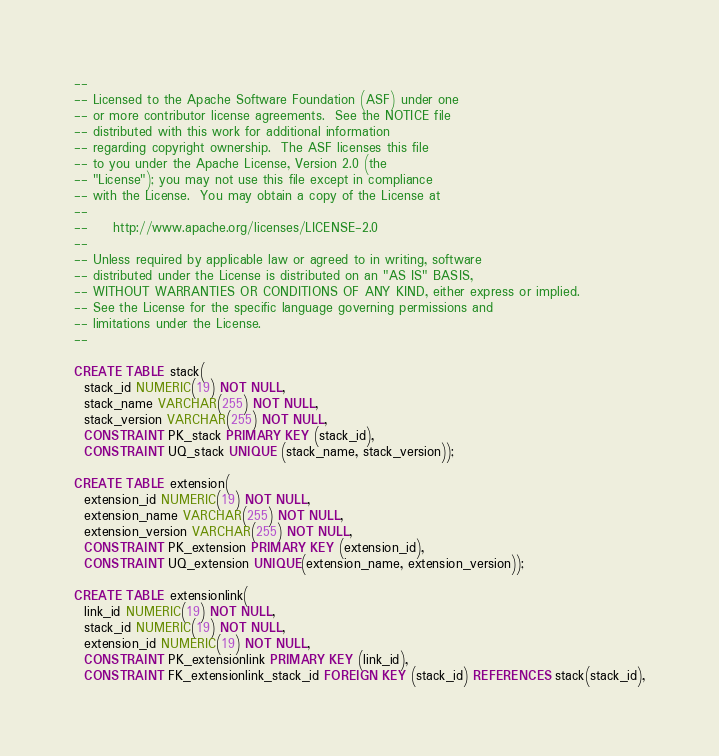<code> <loc_0><loc_0><loc_500><loc_500><_SQL_>--
-- Licensed to the Apache Software Foundation (ASF) under one
-- or more contributor license agreements.  See the NOTICE file
-- distributed with this work for additional information
-- regarding copyright ownership.  The ASF licenses this file
-- to you under the Apache License, Version 2.0 (the
-- "License"); you may not use this file except in compliance
-- with the License.  You may obtain a copy of the License at
--
--     http://www.apache.org/licenses/LICENSE-2.0
--
-- Unless required by applicable law or agreed to in writing, software
-- distributed under the License is distributed on an "AS IS" BASIS,
-- WITHOUT WARRANTIES OR CONDITIONS OF ANY KIND, either express or implied.
-- See the License for the specific language governing permissions and
-- limitations under the License.
--

CREATE TABLE stack(
  stack_id NUMERIC(19) NOT NULL,
  stack_name VARCHAR(255) NOT NULL,
  stack_version VARCHAR(255) NOT NULL,
  CONSTRAINT PK_stack PRIMARY KEY (stack_id),
  CONSTRAINT UQ_stack UNIQUE (stack_name, stack_version));

CREATE TABLE extension(
  extension_id NUMERIC(19) NOT NULL,
  extension_name VARCHAR(255) NOT NULL,
  extension_version VARCHAR(255) NOT NULL,
  CONSTRAINT PK_extension PRIMARY KEY (extension_id),
  CONSTRAINT UQ_extension UNIQUE(extension_name, extension_version));

CREATE TABLE extensionlink(
  link_id NUMERIC(19) NOT NULL,
  stack_id NUMERIC(19) NOT NULL,
  extension_id NUMERIC(19) NOT NULL,
  CONSTRAINT PK_extensionlink PRIMARY KEY (link_id),
  CONSTRAINT FK_extensionlink_stack_id FOREIGN KEY (stack_id) REFERENCES stack(stack_id),</code> 